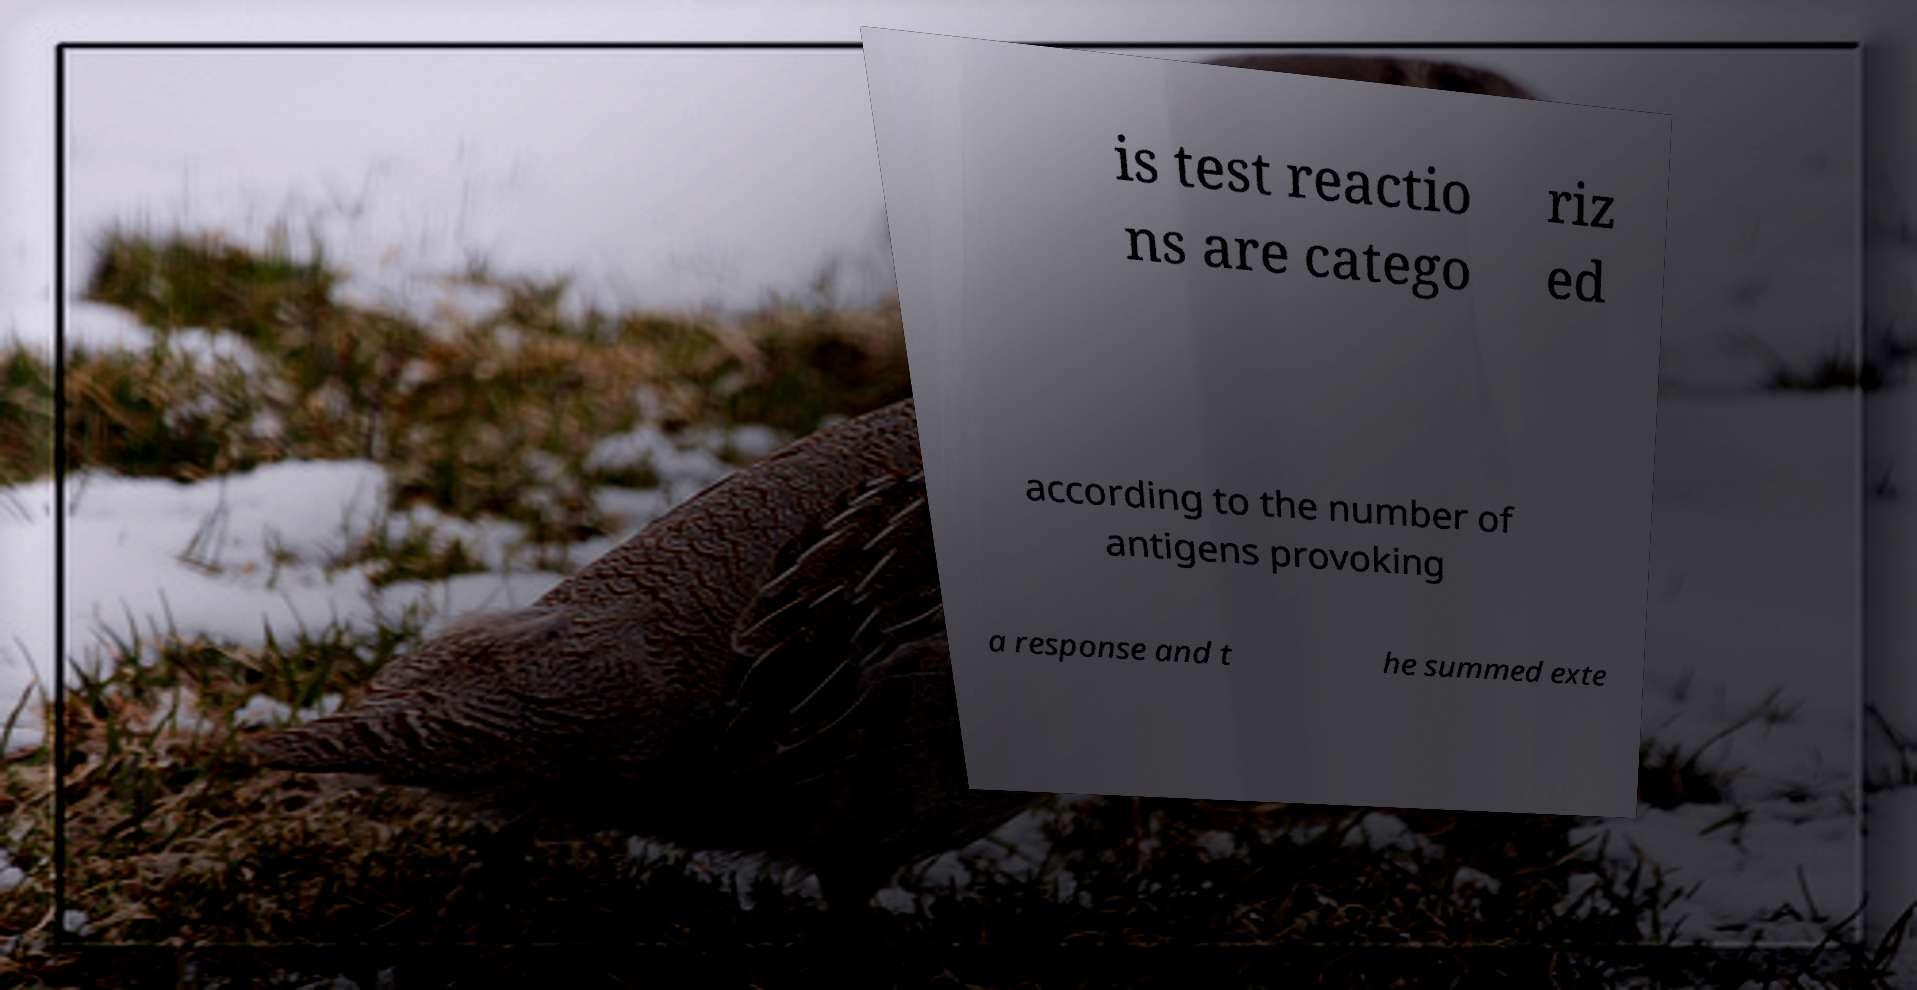Could you assist in decoding the text presented in this image and type it out clearly? is test reactio ns are catego riz ed according to the number of antigens provoking a response and t he summed exte 